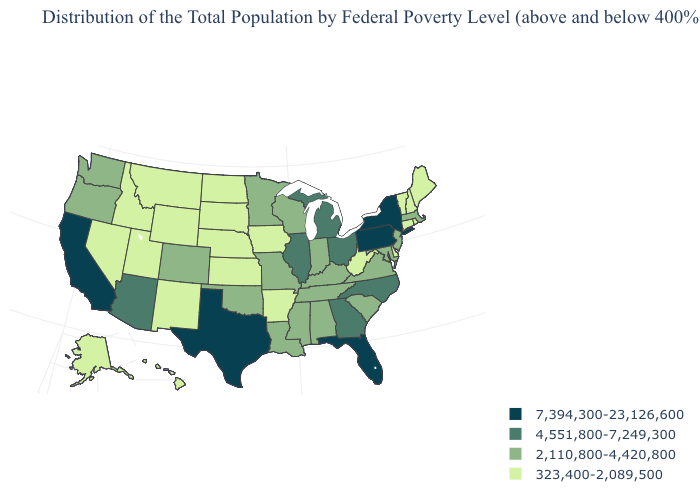What is the highest value in the West ?
Short answer required. 7,394,300-23,126,600. Name the states that have a value in the range 4,551,800-7,249,300?
Give a very brief answer. Arizona, Georgia, Illinois, Michigan, North Carolina, Ohio. Which states have the lowest value in the South?
Give a very brief answer. Arkansas, Delaware, West Virginia. What is the value of Florida?
Answer briefly. 7,394,300-23,126,600. Does California have the highest value in the USA?
Answer briefly. Yes. Does the map have missing data?
Concise answer only. No. What is the highest value in states that border Maine?
Quick response, please. 323,400-2,089,500. Which states hav the highest value in the West?
Be succinct. California. Name the states that have a value in the range 4,551,800-7,249,300?
Answer briefly. Arizona, Georgia, Illinois, Michigan, North Carolina, Ohio. Which states have the highest value in the USA?
Concise answer only. California, Florida, New York, Pennsylvania, Texas. Among the states that border Washington , does Idaho have the highest value?
Be succinct. No. Name the states that have a value in the range 7,394,300-23,126,600?
Write a very short answer. California, Florida, New York, Pennsylvania, Texas. Is the legend a continuous bar?
Be succinct. No. What is the lowest value in the USA?
Be succinct. 323,400-2,089,500. 